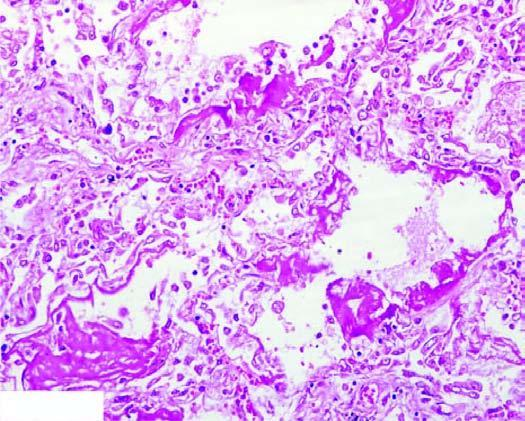what are there of collapsed and dilated alveolar spaces, many of which are lined by eosinophilic hyaline membranes?
Answer the question using a single word or phrase. Alternate areas 